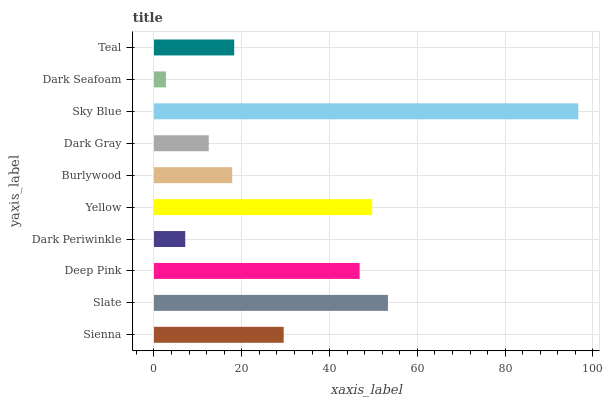Is Dark Seafoam the minimum?
Answer yes or no. Yes. Is Sky Blue the maximum?
Answer yes or no. Yes. Is Slate the minimum?
Answer yes or no. No. Is Slate the maximum?
Answer yes or no. No. Is Slate greater than Sienna?
Answer yes or no. Yes. Is Sienna less than Slate?
Answer yes or no. Yes. Is Sienna greater than Slate?
Answer yes or no. No. Is Slate less than Sienna?
Answer yes or no. No. Is Sienna the high median?
Answer yes or no. Yes. Is Teal the low median?
Answer yes or no. Yes. Is Dark Seafoam the high median?
Answer yes or no. No. Is Dark Seafoam the low median?
Answer yes or no. No. 